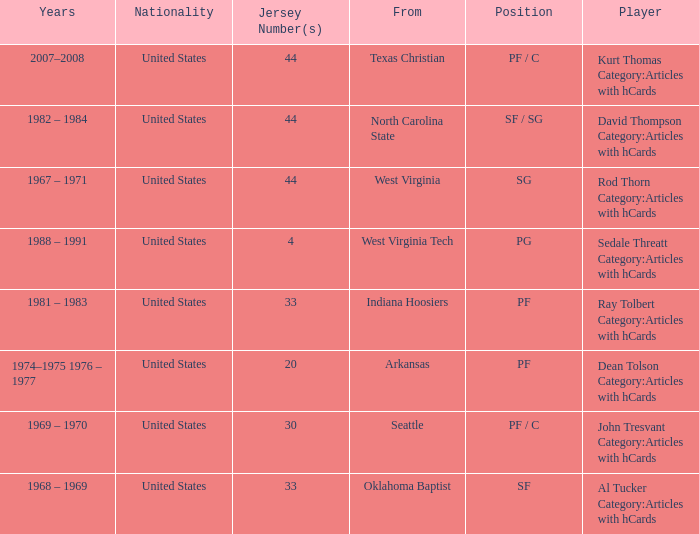What was the highest jersey number for the player from oklahoma baptist? 33.0. 